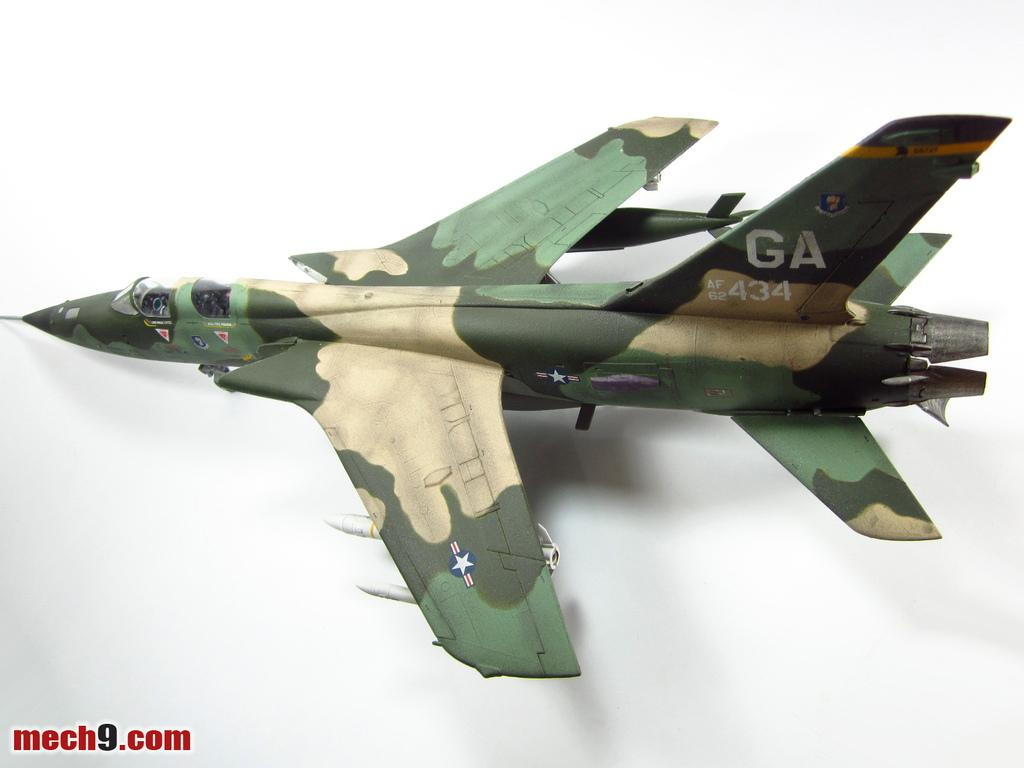Provide a one-sentence caption for the provided image. A camouflaged jet has the letters GA on the tail. 